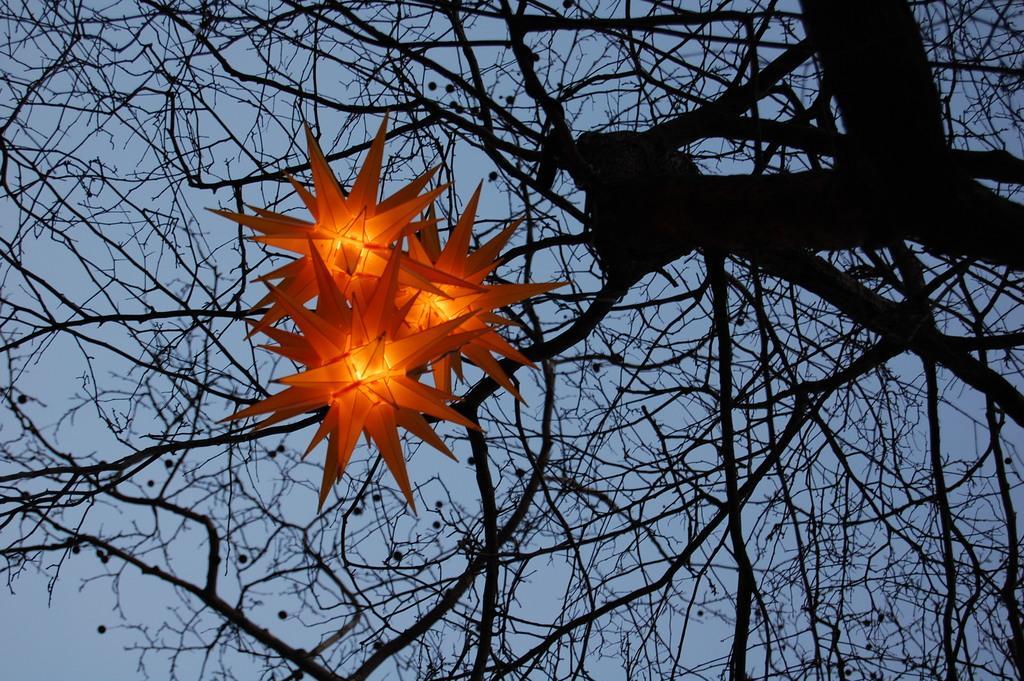In one or two sentences, can you explain what this image depicts? In this image there are lights and there is dry tree. 